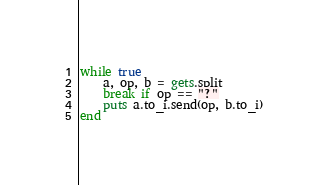Convert code to text. <code><loc_0><loc_0><loc_500><loc_500><_Ruby_>while true
	a, op, b = gets.split
	break if op == "?"
	puts a.to_i.send(op, b.to_i)
end</code> 